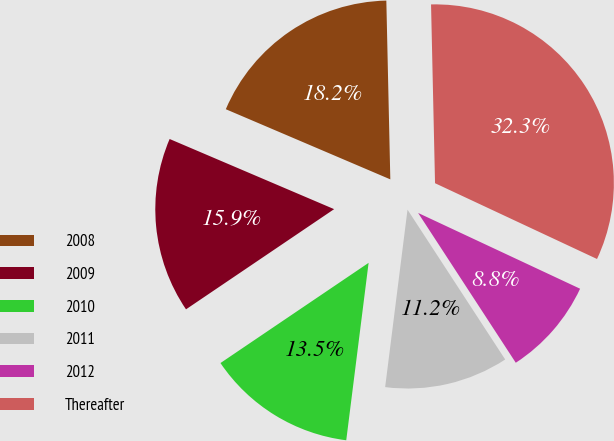Convert chart. <chart><loc_0><loc_0><loc_500><loc_500><pie_chart><fcel>2008<fcel>2009<fcel>2010<fcel>2011<fcel>2012<fcel>Thereafter<nl><fcel>18.23%<fcel>15.88%<fcel>13.54%<fcel>11.19%<fcel>8.84%<fcel>32.32%<nl></chart> 